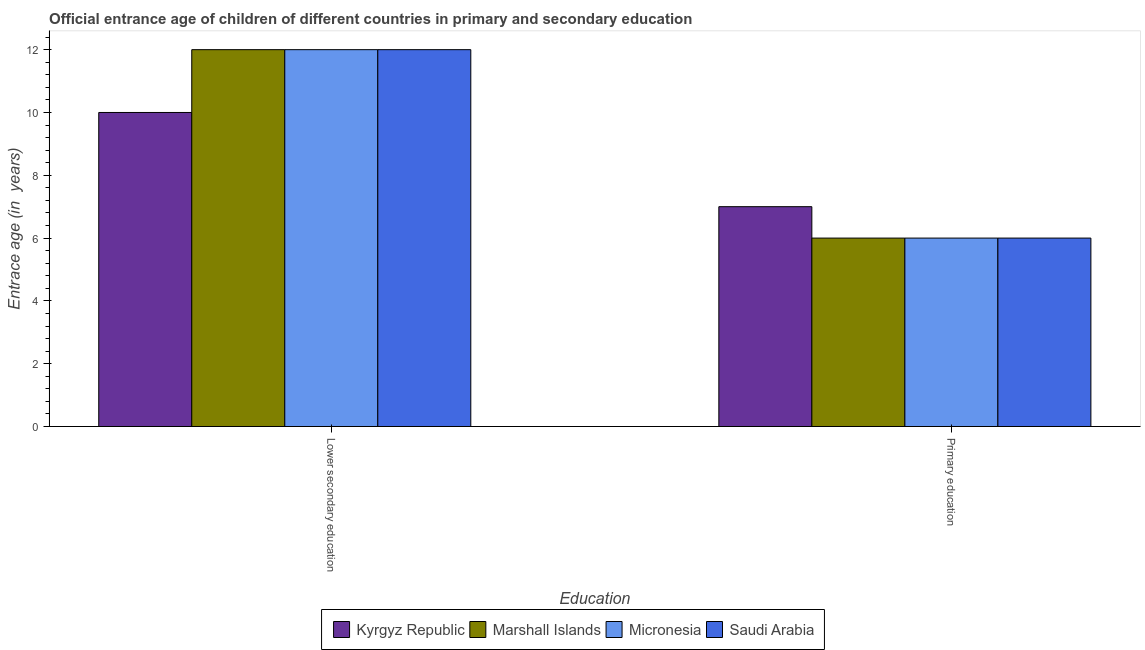Are the number of bars per tick equal to the number of legend labels?
Provide a short and direct response. Yes. How many bars are there on the 2nd tick from the left?
Offer a terse response. 4. What is the entrance age of children in lower secondary education in Micronesia?
Keep it short and to the point. 12. Across all countries, what is the maximum entrance age of children in lower secondary education?
Offer a very short reply. 12. Across all countries, what is the minimum entrance age of children in lower secondary education?
Your answer should be very brief. 10. In which country was the entrance age of chiildren in primary education maximum?
Provide a succinct answer. Kyrgyz Republic. In which country was the entrance age of chiildren in primary education minimum?
Offer a terse response. Marshall Islands. What is the total entrance age of chiildren in primary education in the graph?
Ensure brevity in your answer.  25. What is the difference between the entrance age of chiildren in primary education in Saudi Arabia and that in Kyrgyz Republic?
Ensure brevity in your answer.  -1. What is the difference between the entrance age of children in lower secondary education in Marshall Islands and the entrance age of chiildren in primary education in Saudi Arabia?
Give a very brief answer. 6. What is the average entrance age of children in lower secondary education per country?
Keep it short and to the point. 11.5. In how many countries, is the entrance age of children in lower secondary education greater than 1.2000000000000002 years?
Your answer should be compact. 4. What does the 3rd bar from the left in Lower secondary education represents?
Provide a short and direct response. Micronesia. What does the 2nd bar from the right in Lower secondary education represents?
Make the answer very short. Micronesia. How many bars are there?
Keep it short and to the point. 8. How many countries are there in the graph?
Make the answer very short. 4. Does the graph contain any zero values?
Your answer should be compact. No. How are the legend labels stacked?
Keep it short and to the point. Horizontal. What is the title of the graph?
Offer a terse response. Official entrance age of children of different countries in primary and secondary education. Does "Philippines" appear as one of the legend labels in the graph?
Give a very brief answer. No. What is the label or title of the X-axis?
Your answer should be compact. Education. What is the label or title of the Y-axis?
Provide a short and direct response. Entrace age (in  years). What is the Entrace age (in  years) of Kyrgyz Republic in Lower secondary education?
Make the answer very short. 10. What is the Entrace age (in  years) in Micronesia in Lower secondary education?
Make the answer very short. 12. What is the Entrace age (in  years) of Kyrgyz Republic in Primary education?
Your answer should be compact. 7. What is the Entrace age (in  years) in Saudi Arabia in Primary education?
Keep it short and to the point. 6. Across all Education, what is the maximum Entrace age (in  years) in Marshall Islands?
Your answer should be compact. 12. Across all Education, what is the maximum Entrace age (in  years) of Micronesia?
Offer a very short reply. 12. Across all Education, what is the maximum Entrace age (in  years) of Saudi Arabia?
Offer a terse response. 12. Across all Education, what is the minimum Entrace age (in  years) of Saudi Arabia?
Ensure brevity in your answer.  6. What is the total Entrace age (in  years) of Marshall Islands in the graph?
Offer a very short reply. 18. What is the total Entrace age (in  years) in Micronesia in the graph?
Give a very brief answer. 18. What is the total Entrace age (in  years) of Saudi Arabia in the graph?
Provide a succinct answer. 18. What is the difference between the Entrace age (in  years) of Kyrgyz Republic in Lower secondary education and that in Primary education?
Your response must be concise. 3. What is the difference between the Entrace age (in  years) of Kyrgyz Republic in Lower secondary education and the Entrace age (in  years) of Micronesia in Primary education?
Ensure brevity in your answer.  4. What is the average Entrace age (in  years) in Kyrgyz Republic per Education?
Ensure brevity in your answer.  8.5. What is the difference between the Entrace age (in  years) in Kyrgyz Republic and Entrace age (in  years) in Marshall Islands in Lower secondary education?
Give a very brief answer. -2. What is the difference between the Entrace age (in  years) of Marshall Islands and Entrace age (in  years) of Micronesia in Lower secondary education?
Offer a very short reply. 0. What is the difference between the Entrace age (in  years) of Marshall Islands and Entrace age (in  years) of Saudi Arabia in Lower secondary education?
Make the answer very short. 0. What is the difference between the Entrace age (in  years) of Micronesia and Entrace age (in  years) of Saudi Arabia in Lower secondary education?
Your answer should be very brief. 0. What is the difference between the Entrace age (in  years) of Kyrgyz Republic and Entrace age (in  years) of Micronesia in Primary education?
Provide a short and direct response. 1. What is the ratio of the Entrace age (in  years) of Kyrgyz Republic in Lower secondary education to that in Primary education?
Offer a terse response. 1.43. What is the ratio of the Entrace age (in  years) of Micronesia in Lower secondary education to that in Primary education?
Ensure brevity in your answer.  2. What is the ratio of the Entrace age (in  years) of Saudi Arabia in Lower secondary education to that in Primary education?
Your response must be concise. 2. What is the difference between the highest and the second highest Entrace age (in  years) of Kyrgyz Republic?
Your answer should be very brief. 3. What is the difference between the highest and the second highest Entrace age (in  years) of Micronesia?
Provide a short and direct response. 6. What is the difference between the highest and the lowest Entrace age (in  years) of Micronesia?
Your answer should be very brief. 6. 